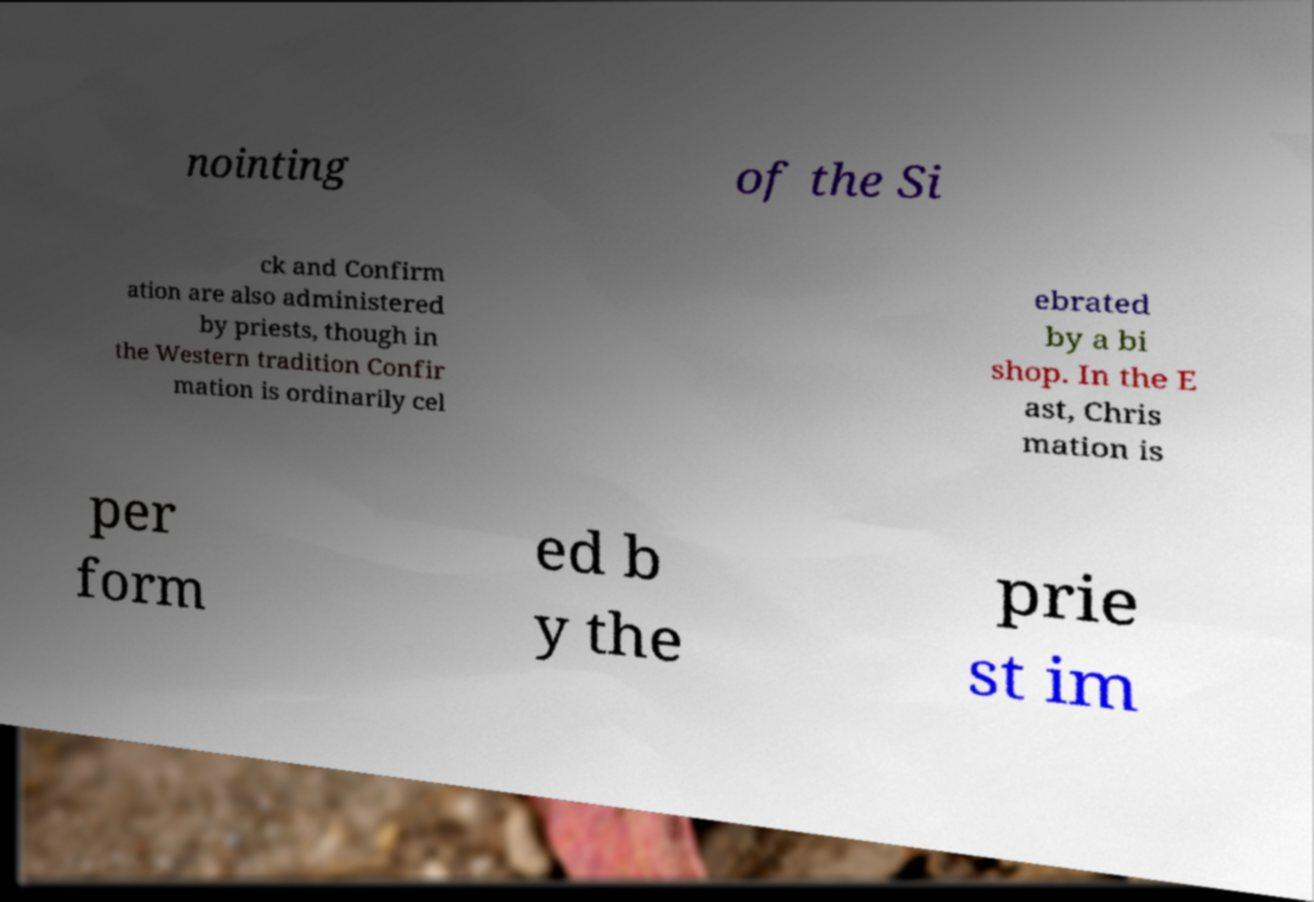What messages or text are displayed in this image? I need them in a readable, typed format. nointing of the Si ck and Confirm ation are also administered by priests, though in the Western tradition Confir mation is ordinarily cel ebrated by a bi shop. In the E ast, Chris mation is per form ed b y the prie st im 